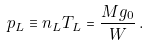Convert formula to latex. <formula><loc_0><loc_0><loc_500><loc_500>p _ { L } \equiv n _ { L } T _ { L } = \frac { M g _ { 0 } } { W } \, .</formula> 